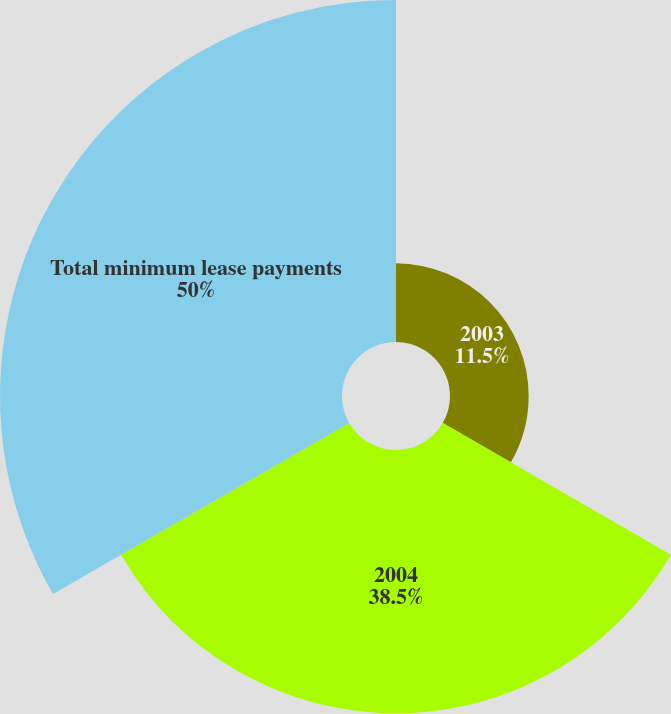Convert chart to OTSL. <chart><loc_0><loc_0><loc_500><loc_500><pie_chart><fcel>2003<fcel>2004<fcel>Total minimum lease payments<nl><fcel>11.5%<fcel>38.5%<fcel>50.0%<nl></chart> 